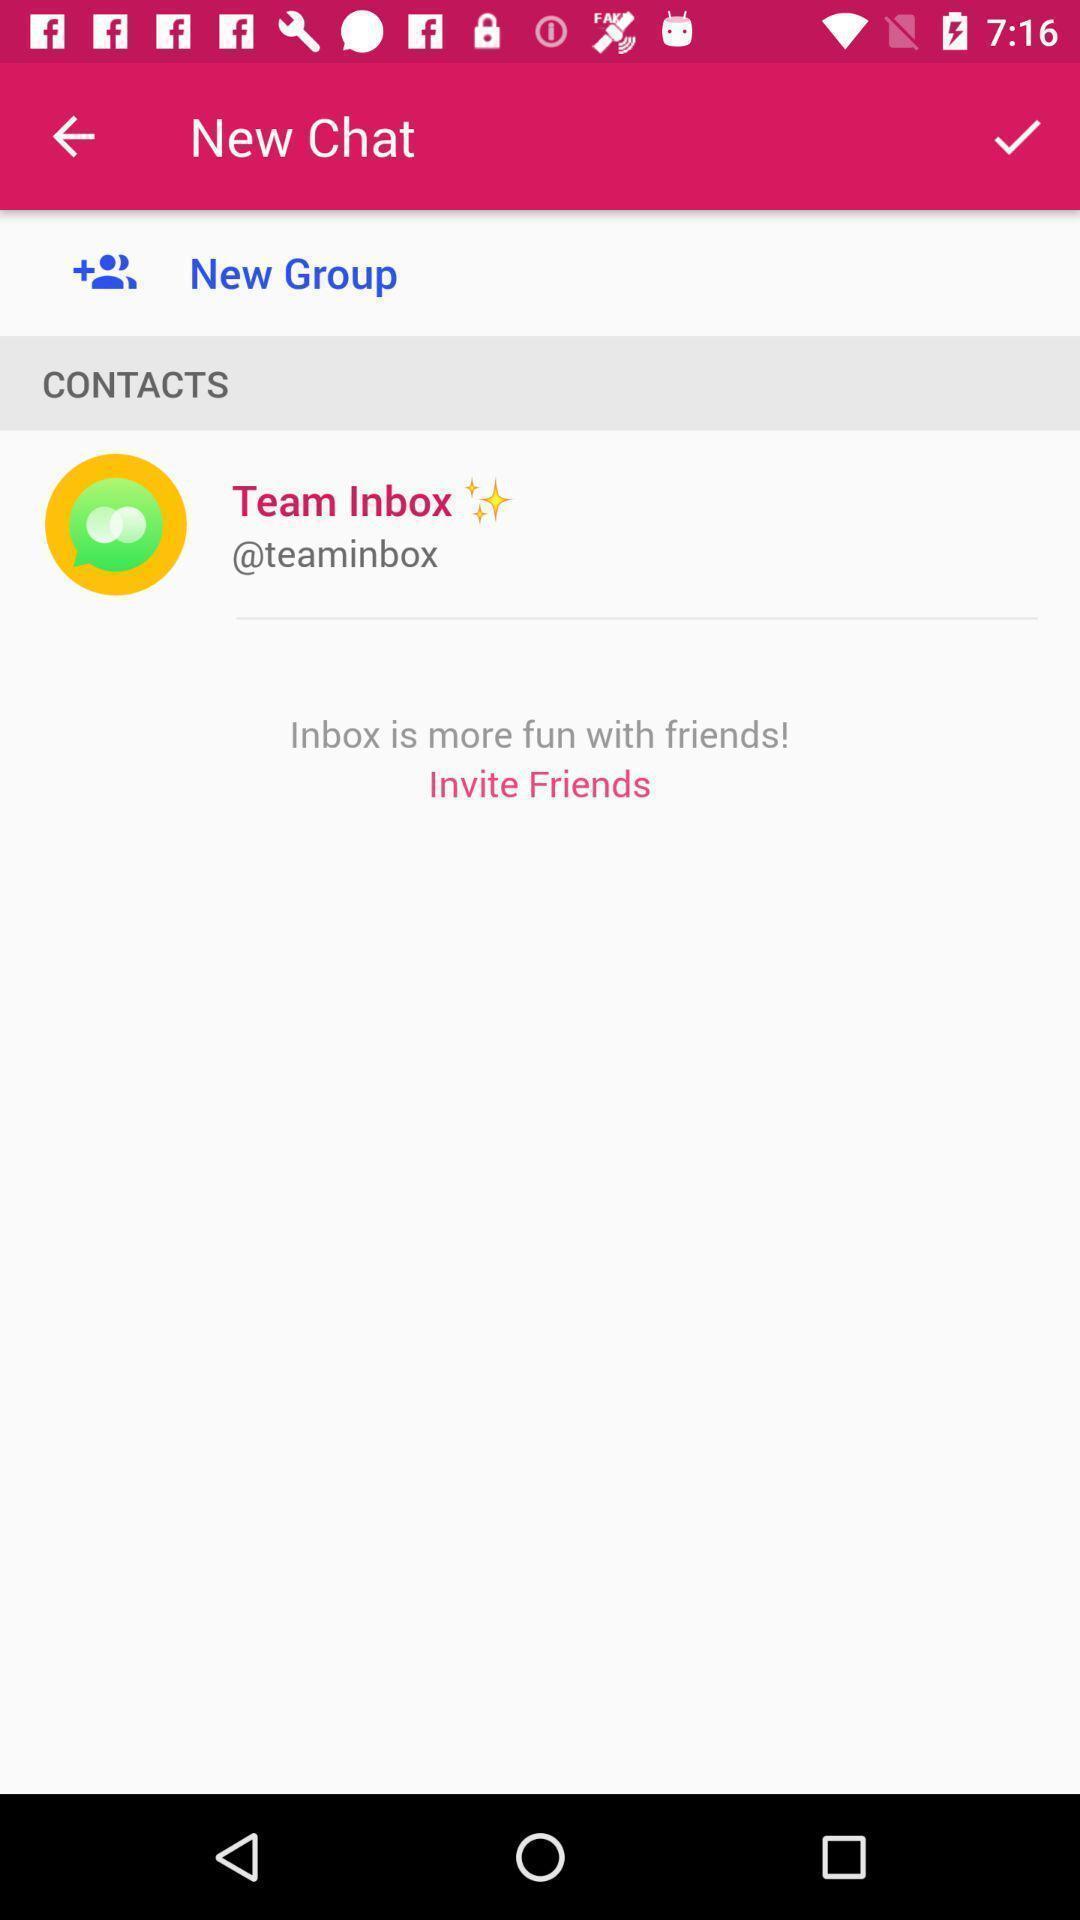Provide a textual representation of this image. Social app for chat displaying to create new friends. 